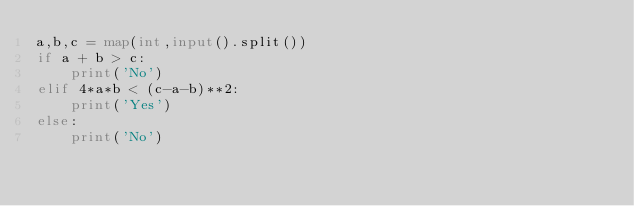Convert code to text. <code><loc_0><loc_0><loc_500><loc_500><_Python_>a,b,c = map(int,input().split())
if a + b > c:
    print('No')
elif 4*a*b < (c-a-b)**2:
    print('Yes')
else:
    print('No')</code> 